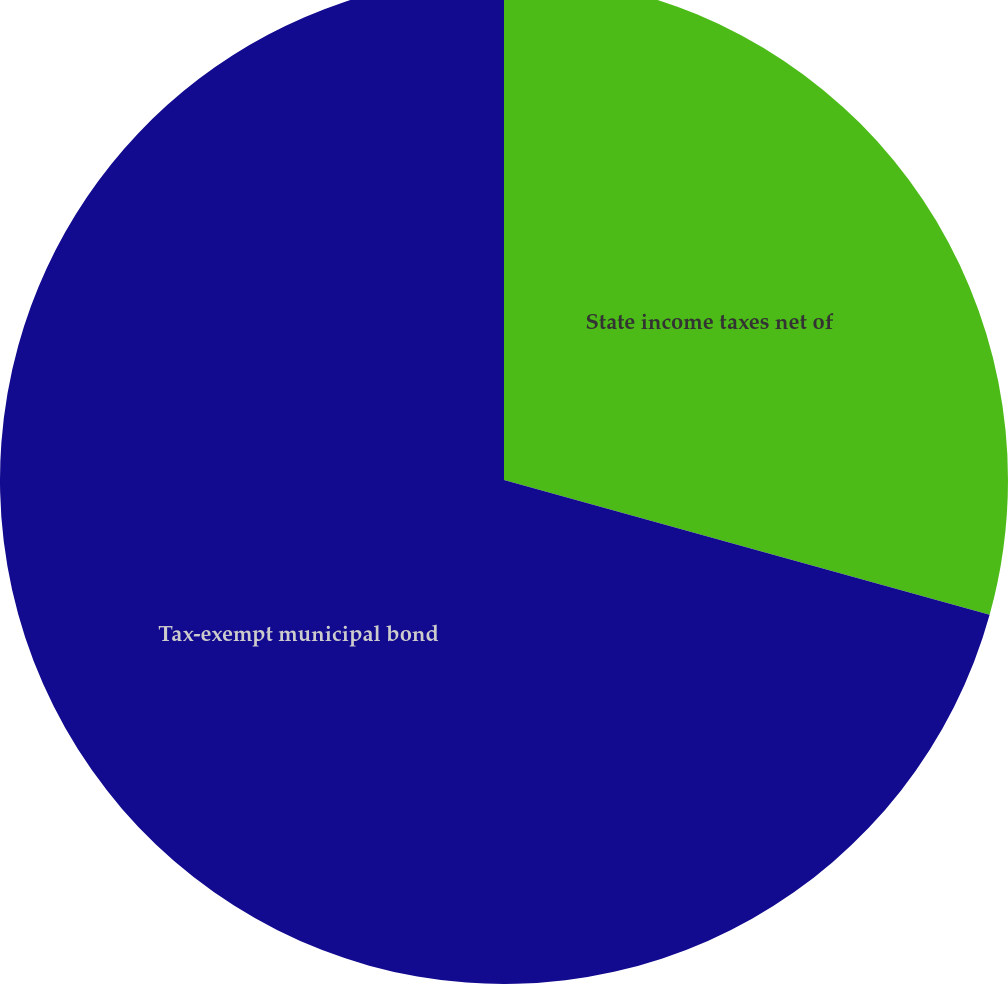<chart> <loc_0><loc_0><loc_500><loc_500><pie_chart><fcel>State income taxes net of<fcel>Tax-exempt municipal bond<nl><fcel>29.31%<fcel>70.69%<nl></chart> 